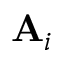<formula> <loc_0><loc_0><loc_500><loc_500>A _ { i }</formula> 